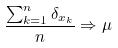Convert formula to latex. <formula><loc_0><loc_0><loc_500><loc_500>\frac { \sum _ { k = 1 } ^ { n } \delta _ { x _ { k } } } { n } \Rightarrow \mu</formula> 